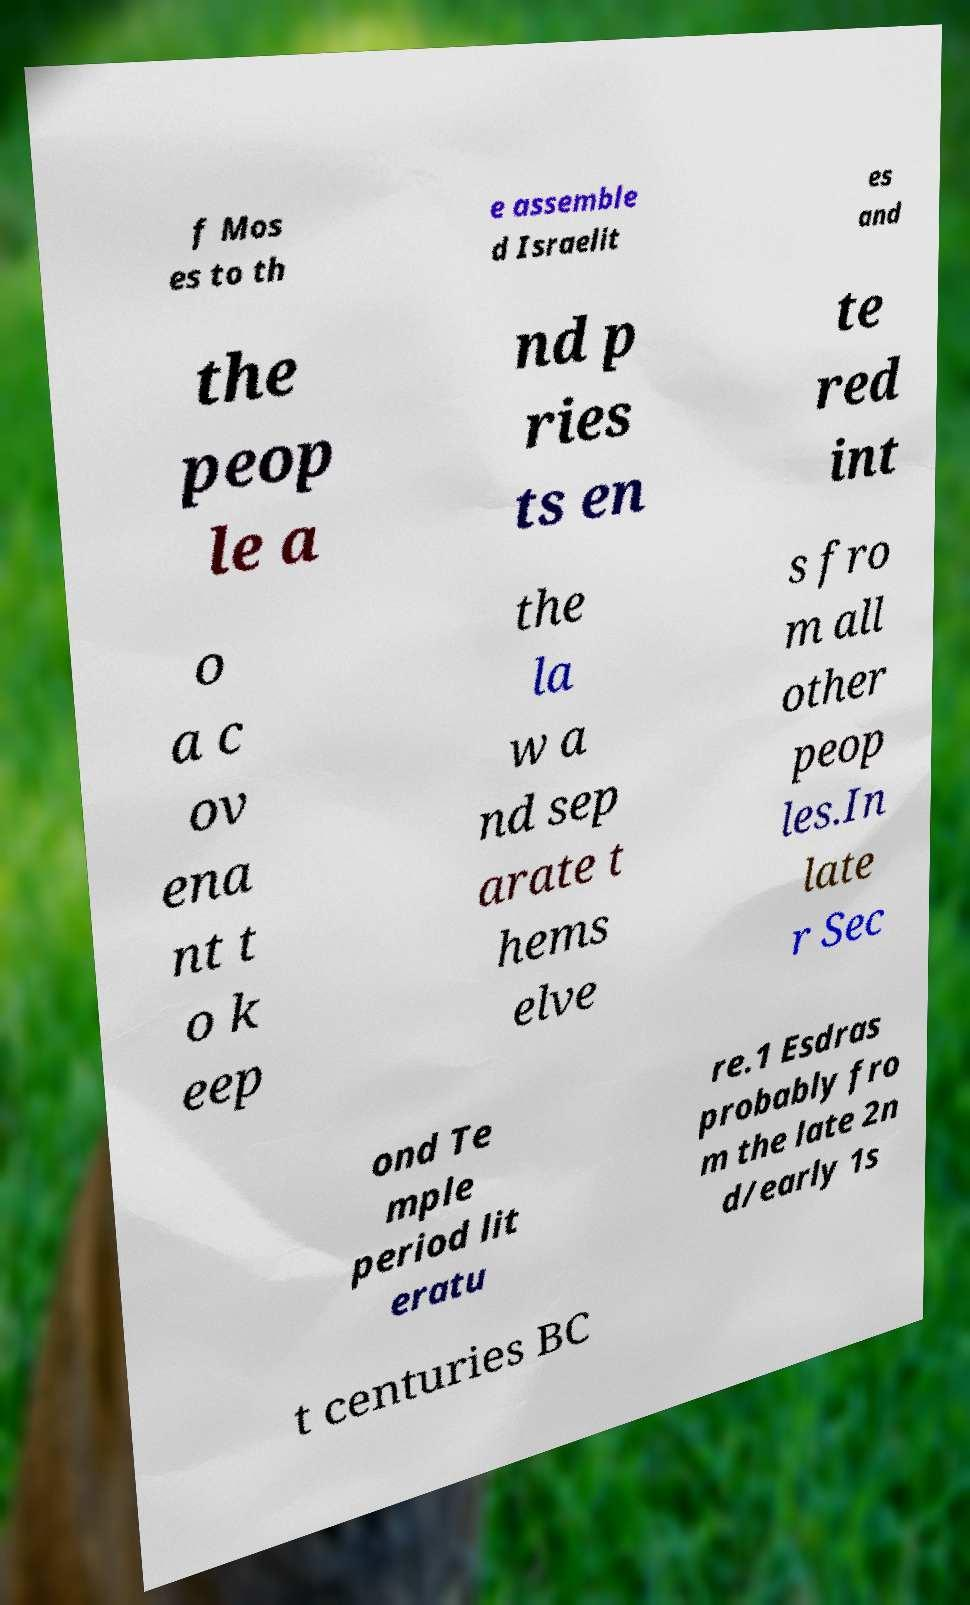Could you assist in decoding the text presented in this image and type it out clearly? f Mos es to th e assemble d Israelit es and the peop le a nd p ries ts en te red int o a c ov ena nt t o k eep the la w a nd sep arate t hems elve s fro m all other peop les.In late r Sec ond Te mple period lit eratu re.1 Esdras probably fro m the late 2n d/early 1s t centuries BC 